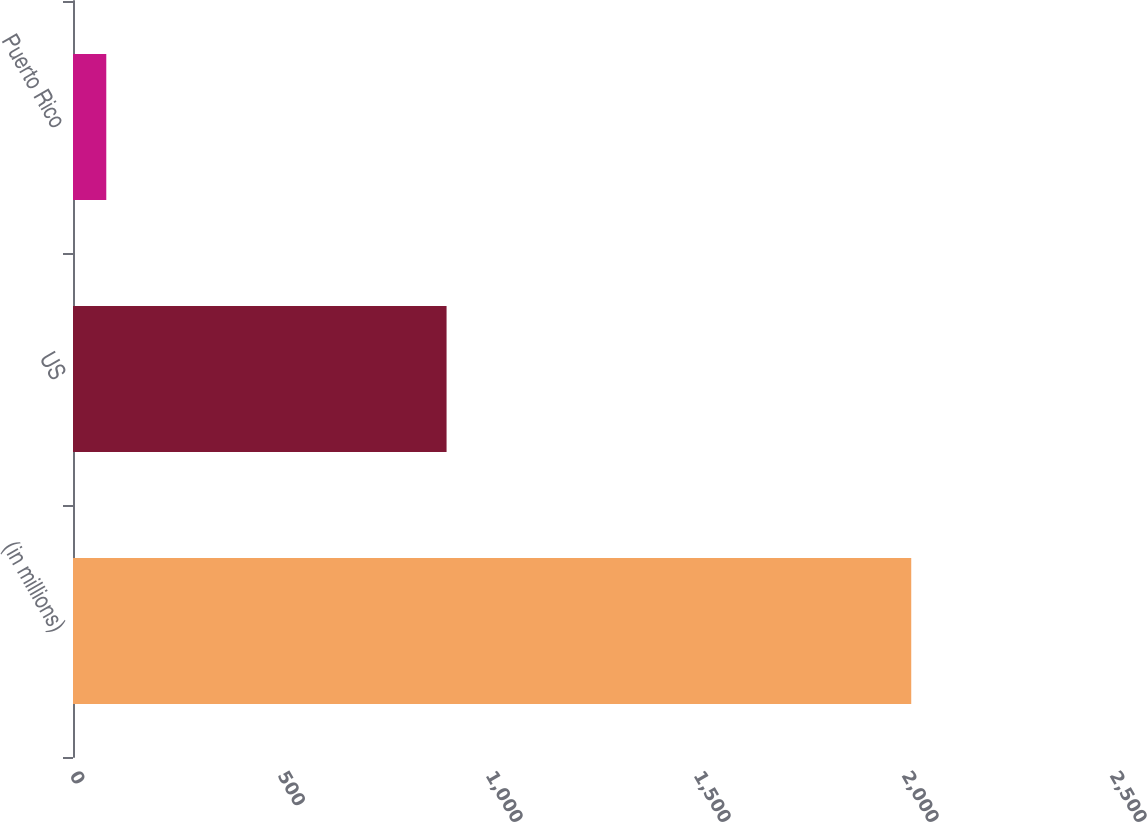Convert chart to OTSL. <chart><loc_0><loc_0><loc_500><loc_500><bar_chart><fcel>(in millions)<fcel>US<fcel>Puerto Rico<nl><fcel>2015<fcel>898<fcel>80<nl></chart> 